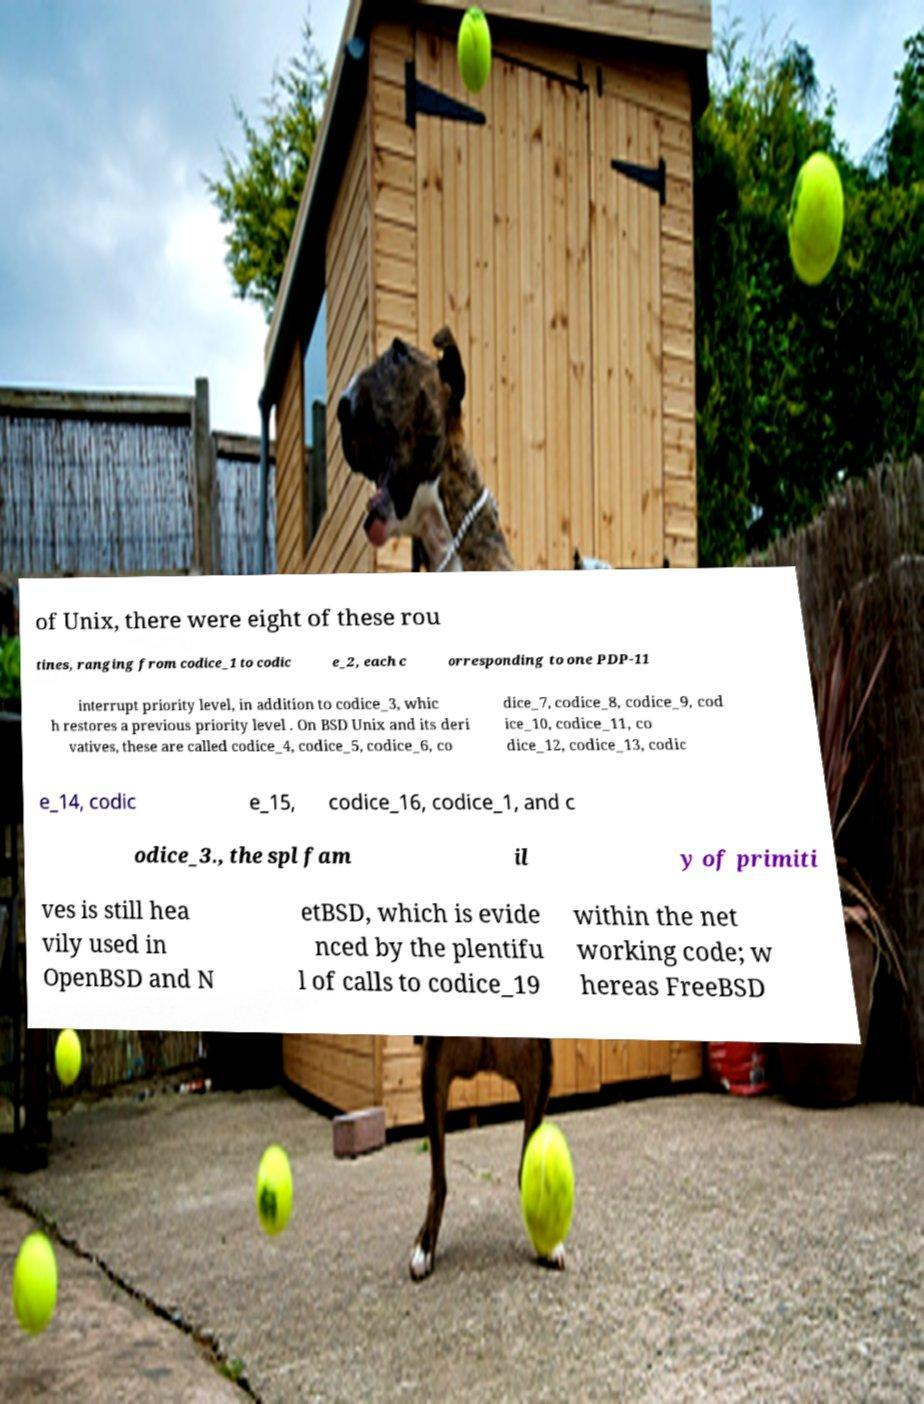Could you extract and type out the text from this image? of Unix, there were eight of these rou tines, ranging from codice_1 to codic e_2, each c orresponding to one PDP-11 interrupt priority level, in addition to codice_3, whic h restores a previous priority level . On BSD Unix and its deri vatives, these are called codice_4, codice_5, codice_6, co dice_7, codice_8, codice_9, cod ice_10, codice_11, co dice_12, codice_13, codic e_14, codic e_15, codice_16, codice_1, and c odice_3., the spl fam il y of primiti ves is still hea vily used in OpenBSD and N etBSD, which is evide nced by the plentifu l of calls to codice_19 within the net working code; w hereas FreeBSD 